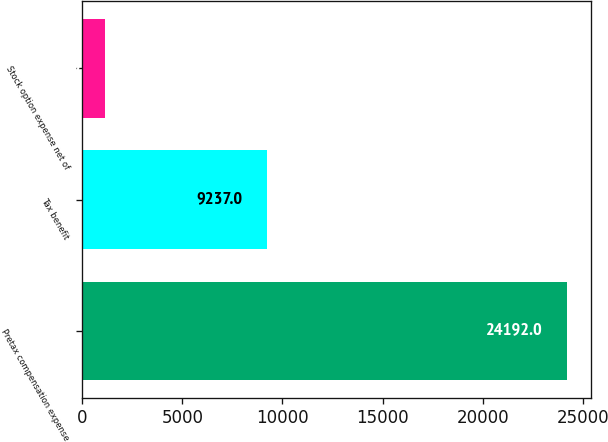Convert chart. <chart><loc_0><loc_0><loc_500><loc_500><bar_chart><fcel>Pretax compensation expense<fcel>Tax benefit<fcel>Stock option expense net of<nl><fcel>24192<fcel>9237<fcel>1133<nl></chart> 